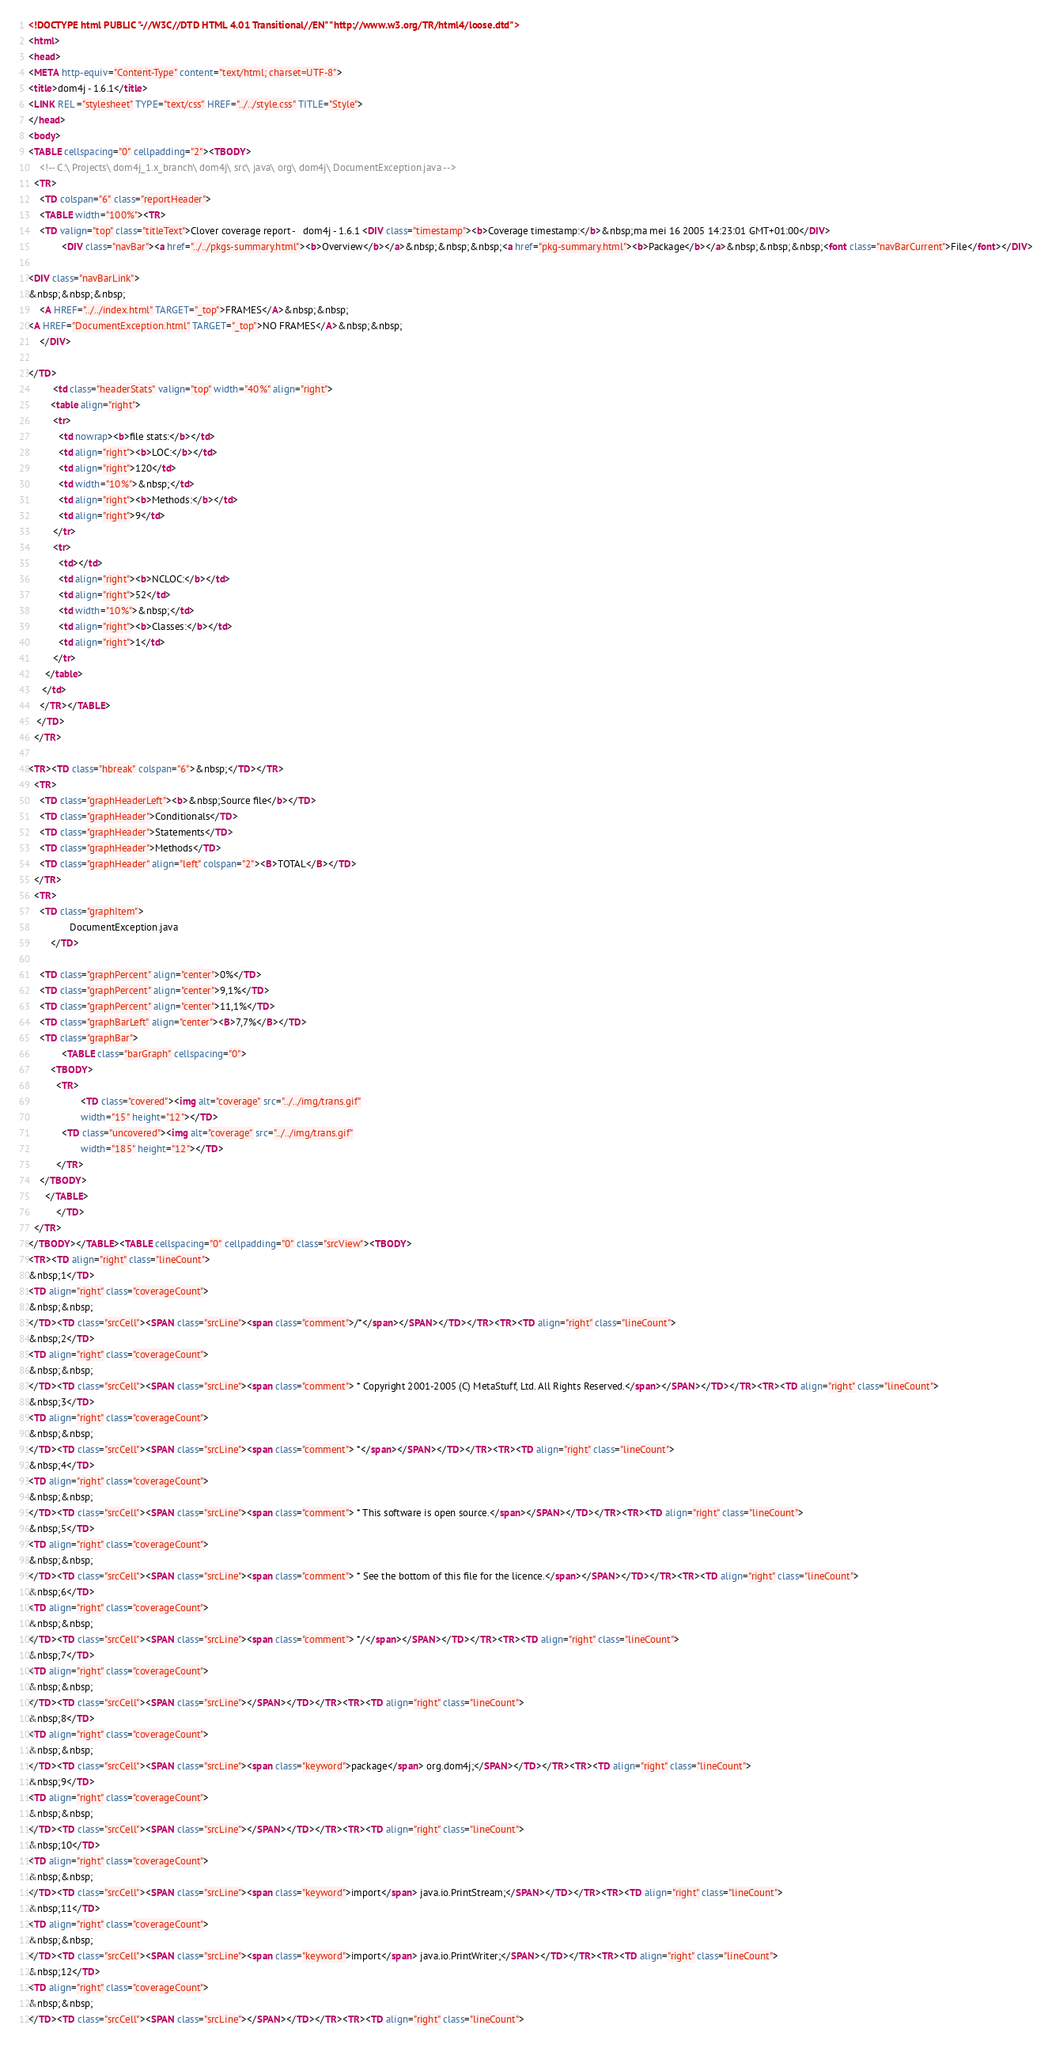<code> <loc_0><loc_0><loc_500><loc_500><_HTML_><!DOCTYPE html PUBLIC "-//W3C//DTD HTML 4.01 Transitional//EN" "http://www.w3.org/TR/html4/loose.dtd">
<html>
<head>
<META http-equiv="Content-Type" content="text/html; charset=UTF-8">
<title>dom4j - 1.6.1</title>
<LINK REL ="stylesheet" TYPE="text/css" HREF="../../style.css" TITLE="Style">
</head>
<body>
<TABLE cellspacing="0" cellpadding="2"><TBODY>
    <!-- C:\ Projects\ dom4j_1.x_branch\ dom4j\ src\ java\ org\ dom4j\ DocumentException.java -->
  <TR>
    <TD colspan="6" class="reportHeader">
    <TABLE width="100%"><TR>
    <TD valign="top" class="titleText">Clover coverage report -   dom4j - 1.6.1 <DIV class="timestamp"><b>Coverage timestamp:</b>&nbsp;ma mei 16 2005 14:23:01 GMT+01:00</DIV>
            <DIV class="navBar"><a href="../../pkgs-summary.html"><b>Overview</b></a>&nbsp;&nbsp;&nbsp;<a href="pkg-summary.html"><b>Package</b></a>&nbsp;&nbsp;&nbsp;<font class="navBarCurrent">File</font></DIV>
    
<DIV class="navBarLink">
&nbsp;&nbsp;&nbsp;
    <A HREF="../../index.html" TARGET="_top">FRAMES</A>&nbsp;&nbsp;
<A HREF="DocumentException.html" TARGET="_top">NO FRAMES</A>&nbsp;&nbsp;
    </DIV>

</TD>
         <td class="headerStats" valign="top" width="40%" align="right">
        <table align="right">
         <tr>
           <td nowrap><b>file stats:</b></td>
           <td align="right"><b>LOC:</b></td>
           <td align="right">120</td>
           <td width="10%">&nbsp;</td>
           <td align="right"><b>Methods:</b></td>
           <td align="right">9</td>
         </tr>
         <tr>
           <td></td>
           <td align="right"><b>NCLOC:</b></td>
           <td align="right">52</td>
           <td width="10%">&nbsp;</td>
           <td align="right"><b>Classes:</b></td>
           <td align="right">1</td>
         </tr>
      </table>
     </td>
    </TR></TABLE>
   </TD>
  </TR>

<TR><TD class="hbreak" colspan="6">&nbsp;</TD></TR>
  <TR>
    <TD class="graphHeaderLeft"><b>&nbsp;Source file</b></TD>
    <TD class="graphHeader">Conditionals</TD>
    <TD class="graphHeader">Statements</TD>
    <TD class="graphHeader">Methods</TD>
    <TD class="graphHeader" align="left" colspan="2"><B>TOTAL</B></TD>
  </TR>   
  <TR>
    <TD class="graphItem">
        	   DocumentException.java
	    </TD>
   
    <TD class="graphPercent" align="center">0%</TD>
    <TD class="graphPercent" align="center">9,1%</TD>
    <TD class="graphPercent" align="center">11,1%</TD>
    <TD class="graphBarLeft" align="center"><B>7,7%</B></TD>
    <TD class="graphBar">
            <TABLE class="barGraph" cellspacing="0">
        <TBODY>
          <TR>
	               <TD class="covered"><img alt="coverage" src="../../img/trans.gif"
                   width="15" height="12"></TD>
            <TD class="uncovered"><img alt="coverage" src="../../img/trans.gif"
                   width="185" height="12"></TD>
	   	  </TR>
	</TBODY>
      </TABLE>
          </TD>
  </TR> 
</TBODY></TABLE><TABLE cellspacing="0" cellpadding="0" class="srcView"><TBODY>
<TR><TD align="right" class="lineCount">
&nbsp;1</TD>
<TD align="right" class="coverageCount">
&nbsp;&nbsp;
</TD><TD class="srcCell"><SPAN class="srcLine"><span class="comment">/*</span></SPAN></TD></TR><TR><TD align="right" class="lineCount">
&nbsp;2</TD>
<TD align="right" class="coverageCount">
&nbsp;&nbsp;
</TD><TD class="srcCell"><SPAN class="srcLine"><span class="comment"> * Copyright 2001-2005 (C) MetaStuff, Ltd. All Rights Reserved.</span></SPAN></TD></TR><TR><TD align="right" class="lineCount">
&nbsp;3</TD>
<TD align="right" class="coverageCount">
&nbsp;&nbsp;
</TD><TD class="srcCell"><SPAN class="srcLine"><span class="comment"> *</span></SPAN></TD></TR><TR><TD align="right" class="lineCount">
&nbsp;4</TD>
<TD align="right" class="coverageCount">
&nbsp;&nbsp;
</TD><TD class="srcCell"><SPAN class="srcLine"><span class="comment"> * This software is open source.</span></SPAN></TD></TR><TR><TD align="right" class="lineCount">
&nbsp;5</TD>
<TD align="right" class="coverageCount">
&nbsp;&nbsp;
</TD><TD class="srcCell"><SPAN class="srcLine"><span class="comment"> * See the bottom of this file for the licence.</span></SPAN></TD></TR><TR><TD align="right" class="lineCount">
&nbsp;6</TD>
<TD align="right" class="coverageCount">
&nbsp;&nbsp;
</TD><TD class="srcCell"><SPAN class="srcLine"><span class="comment"> */</span></SPAN></TD></TR><TR><TD align="right" class="lineCount">
&nbsp;7</TD>
<TD align="right" class="coverageCount">
&nbsp;&nbsp;
</TD><TD class="srcCell"><SPAN class="srcLine"></SPAN></TD></TR><TR><TD align="right" class="lineCount">
&nbsp;8</TD>
<TD align="right" class="coverageCount">
&nbsp;&nbsp;
</TD><TD class="srcCell"><SPAN class="srcLine"><span class="keyword">package</span> org.dom4j;</SPAN></TD></TR><TR><TD align="right" class="lineCount">
&nbsp;9</TD>
<TD align="right" class="coverageCount">
&nbsp;&nbsp;
</TD><TD class="srcCell"><SPAN class="srcLine"></SPAN></TD></TR><TR><TD align="right" class="lineCount">
&nbsp;10</TD>
<TD align="right" class="coverageCount">
&nbsp;&nbsp;
</TD><TD class="srcCell"><SPAN class="srcLine"><span class="keyword">import</span> java.io.PrintStream;</SPAN></TD></TR><TR><TD align="right" class="lineCount">
&nbsp;11</TD>
<TD align="right" class="coverageCount">
&nbsp;&nbsp;
</TD><TD class="srcCell"><SPAN class="srcLine"><span class="keyword">import</span> java.io.PrintWriter;</SPAN></TD></TR><TR><TD align="right" class="lineCount">
&nbsp;12</TD>
<TD align="right" class="coverageCount">
&nbsp;&nbsp;
</TD><TD class="srcCell"><SPAN class="srcLine"></SPAN></TD></TR><TR><TD align="right" class="lineCount"></code> 